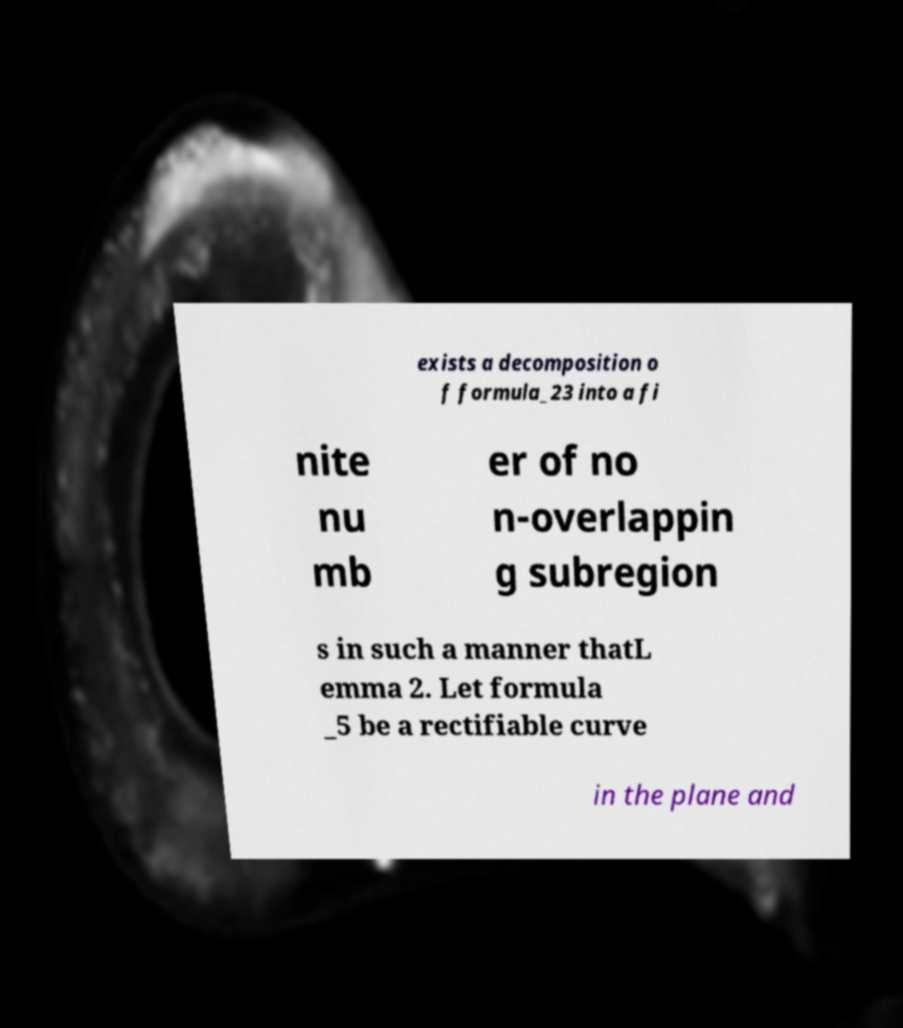There's text embedded in this image that I need extracted. Can you transcribe it verbatim? exists a decomposition o f formula_23 into a fi nite nu mb er of no n-overlappin g subregion s in such a manner thatL emma 2. Let formula _5 be a rectifiable curve in the plane and 